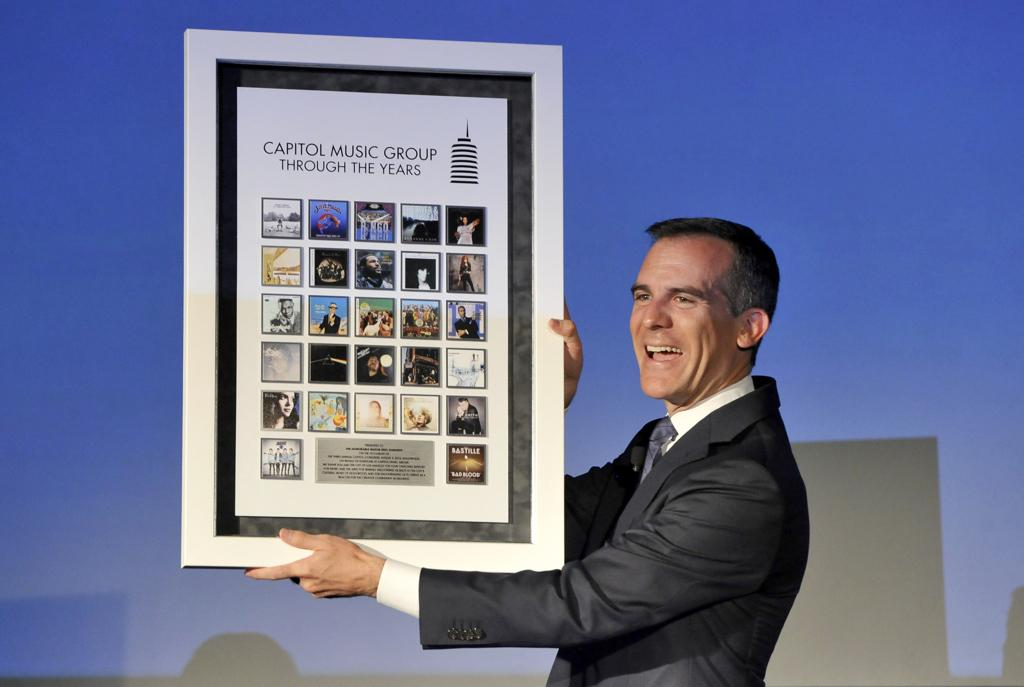Provide a one-sentence caption for the provided image. A man in a suit holding a poster showing differnt cover art for vaious music from Capitol Music group over the years. 